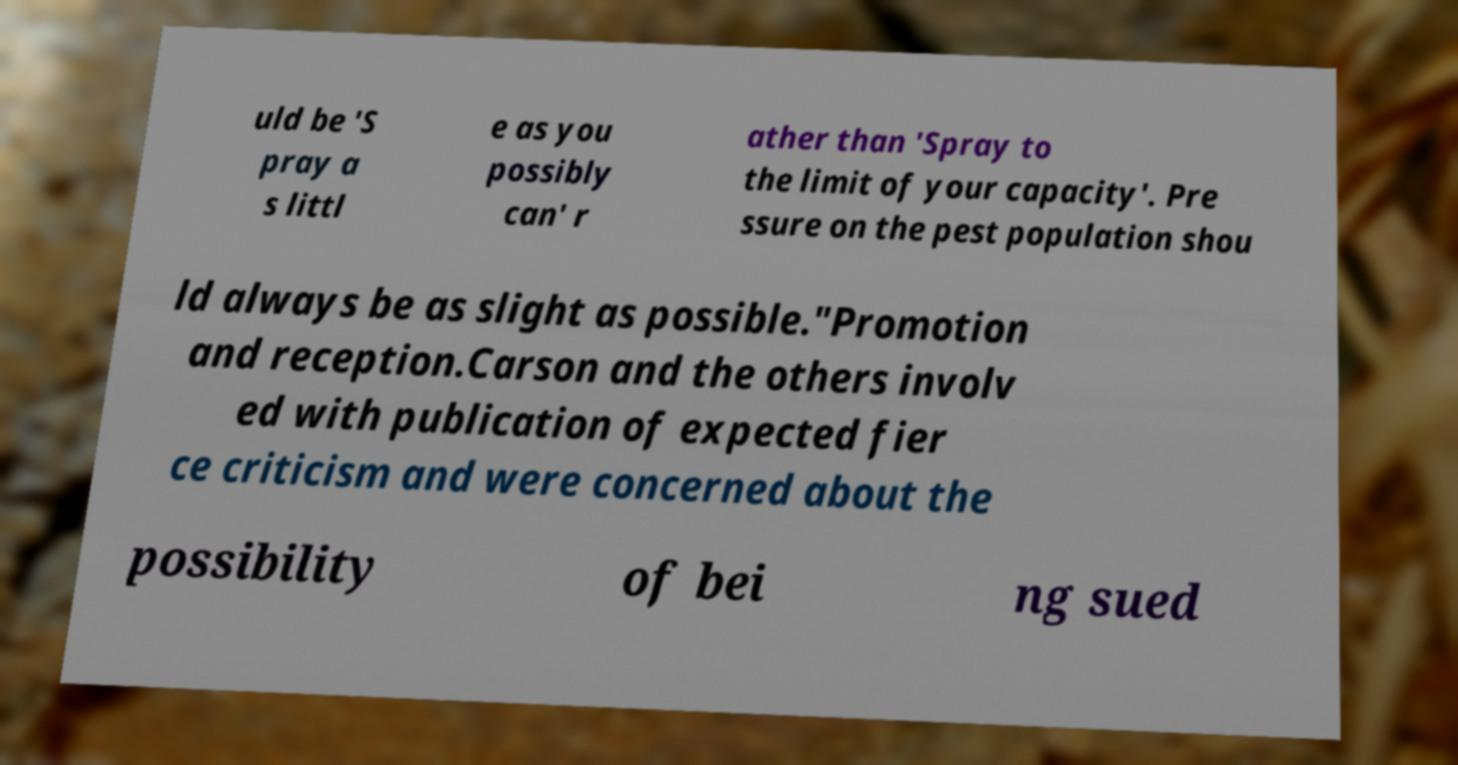Please read and relay the text visible in this image. What does it say? uld be 'S pray a s littl e as you possibly can' r ather than 'Spray to the limit of your capacity'. Pre ssure on the pest population shou ld always be as slight as possible."Promotion and reception.Carson and the others involv ed with publication of expected fier ce criticism and were concerned about the possibility of bei ng sued 